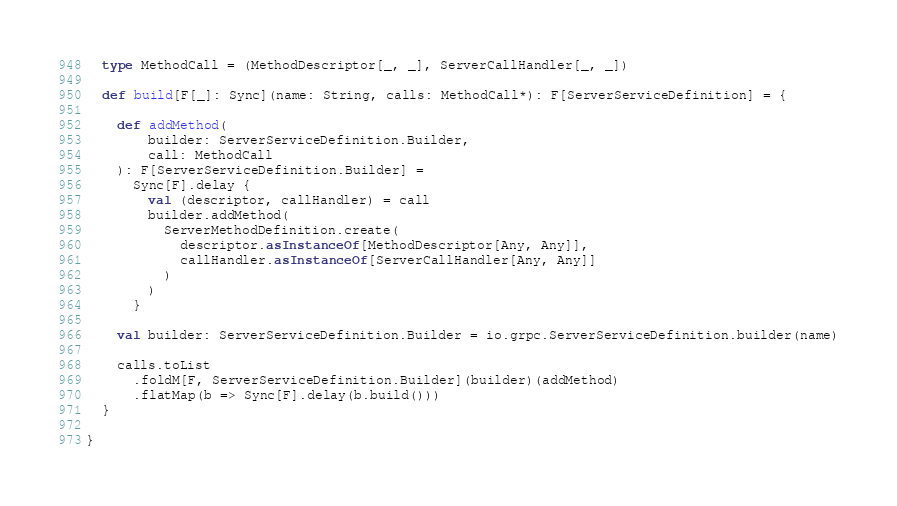Convert code to text. <code><loc_0><loc_0><loc_500><loc_500><_Scala_>  type MethodCall = (MethodDescriptor[_, _], ServerCallHandler[_, _])

  def build[F[_]: Sync](name: String, calls: MethodCall*): F[ServerServiceDefinition] = {

    def addMethod(
        builder: ServerServiceDefinition.Builder,
        call: MethodCall
    ): F[ServerServiceDefinition.Builder] =
      Sync[F].delay {
        val (descriptor, callHandler) = call
        builder.addMethod(
          ServerMethodDefinition.create(
            descriptor.asInstanceOf[MethodDescriptor[Any, Any]],
            callHandler.asInstanceOf[ServerCallHandler[Any, Any]]
          )
        )
      }

    val builder: ServerServiceDefinition.Builder = io.grpc.ServerServiceDefinition.builder(name)

    calls.toList
      .foldM[F, ServerServiceDefinition.Builder](builder)(addMethod)
      .flatMap(b => Sync[F].delay(b.build()))
  }

}
</code> 